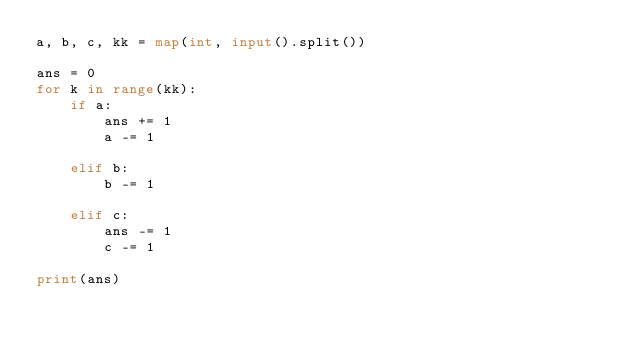<code> <loc_0><loc_0><loc_500><loc_500><_Python_>a, b, c, kk = map(int, input().split())

ans = 0
for k in range(kk):
    if a:
        ans += 1
        a -= 1

    elif b:
        b -= 1

    elif c:
        ans -= 1
        c -= 1

print(ans)
</code> 